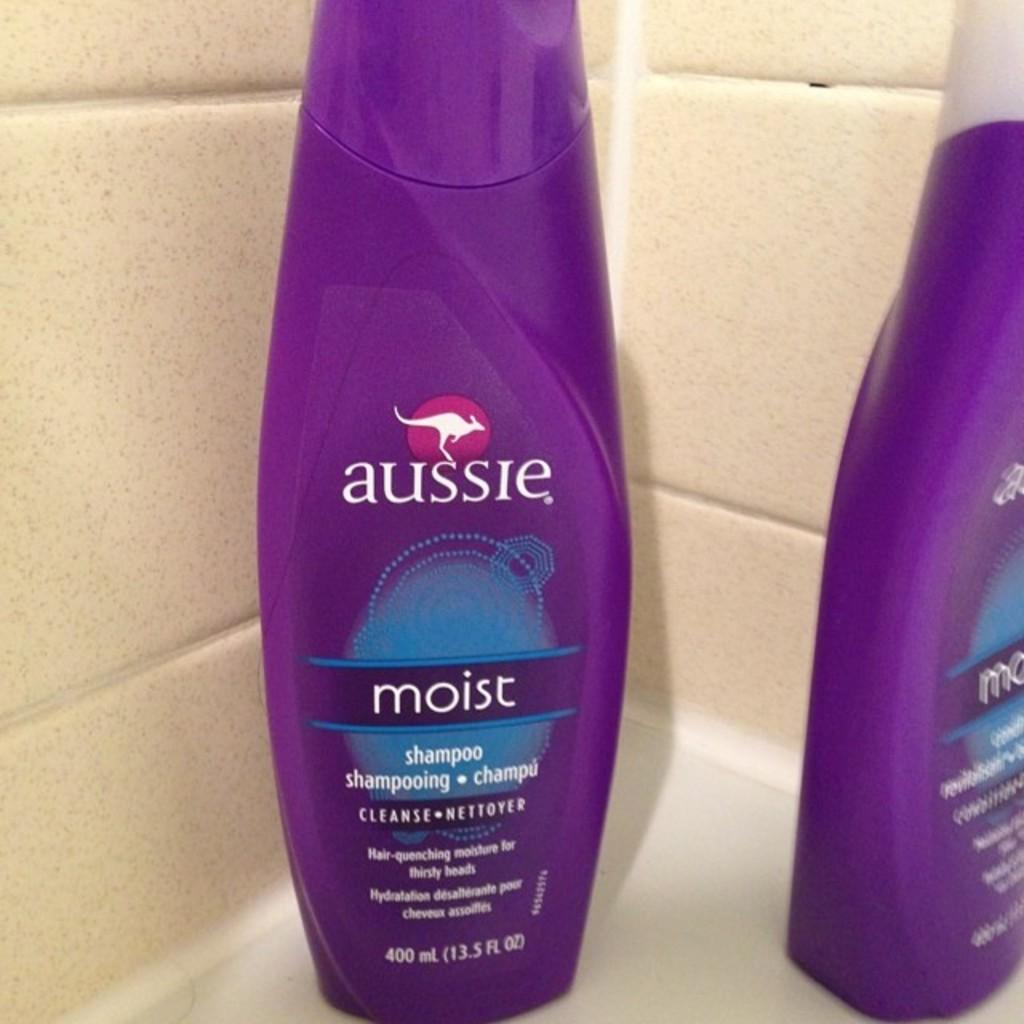<image>
Share a concise interpretation of the image provided. Two bottles of Aussie products sitting in the corner of a tub. 